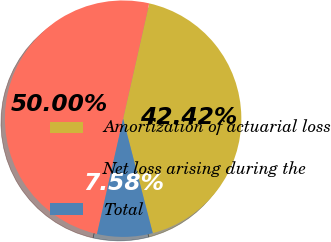Convert chart to OTSL. <chart><loc_0><loc_0><loc_500><loc_500><pie_chart><fcel>Amortization of actuarial loss<fcel>Net loss arising during the<fcel>Total<nl><fcel>42.42%<fcel>50.0%<fcel>7.58%<nl></chart> 